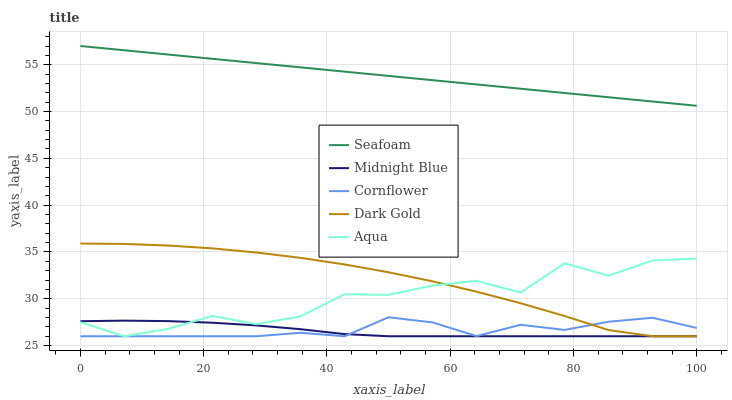Does Midnight Blue have the minimum area under the curve?
Answer yes or no. Yes. Does Seafoam have the maximum area under the curve?
Answer yes or no. Yes. Does Dark Gold have the minimum area under the curve?
Answer yes or no. No. Does Dark Gold have the maximum area under the curve?
Answer yes or no. No. Is Seafoam the smoothest?
Answer yes or no. Yes. Is Aqua the roughest?
Answer yes or no. Yes. Is Dark Gold the smoothest?
Answer yes or no. No. Is Dark Gold the roughest?
Answer yes or no. No. Does Seafoam have the lowest value?
Answer yes or no. No. Does Seafoam have the highest value?
Answer yes or no. Yes. Does Dark Gold have the highest value?
Answer yes or no. No. Is Midnight Blue less than Seafoam?
Answer yes or no. Yes. Is Seafoam greater than Dark Gold?
Answer yes or no. Yes. Does Midnight Blue intersect Seafoam?
Answer yes or no. No. 